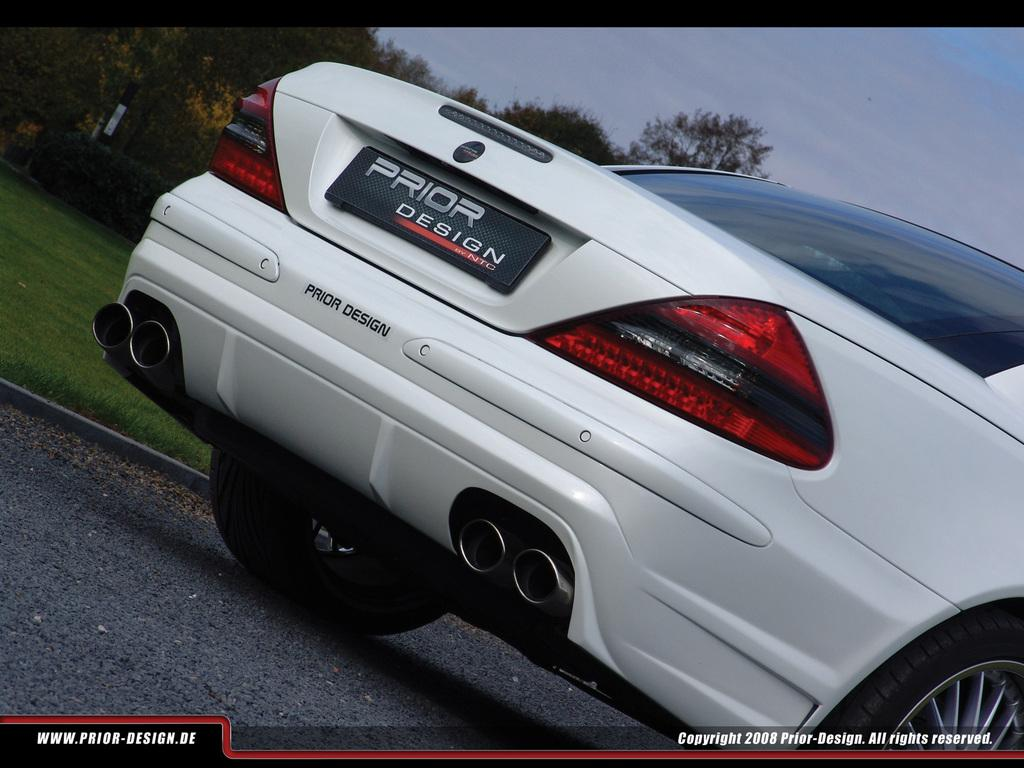What is the main subject of the image? There is a vehicle on the road in the image. What else can be seen in the image besides the vehicle? There is a poster with text and trees, grass, and the sky visible in the background of the image. How many babies are present in the image? There are no babies present in the image. What type of meal is being prepared in the image? There is no meal preparation visible in the image. 